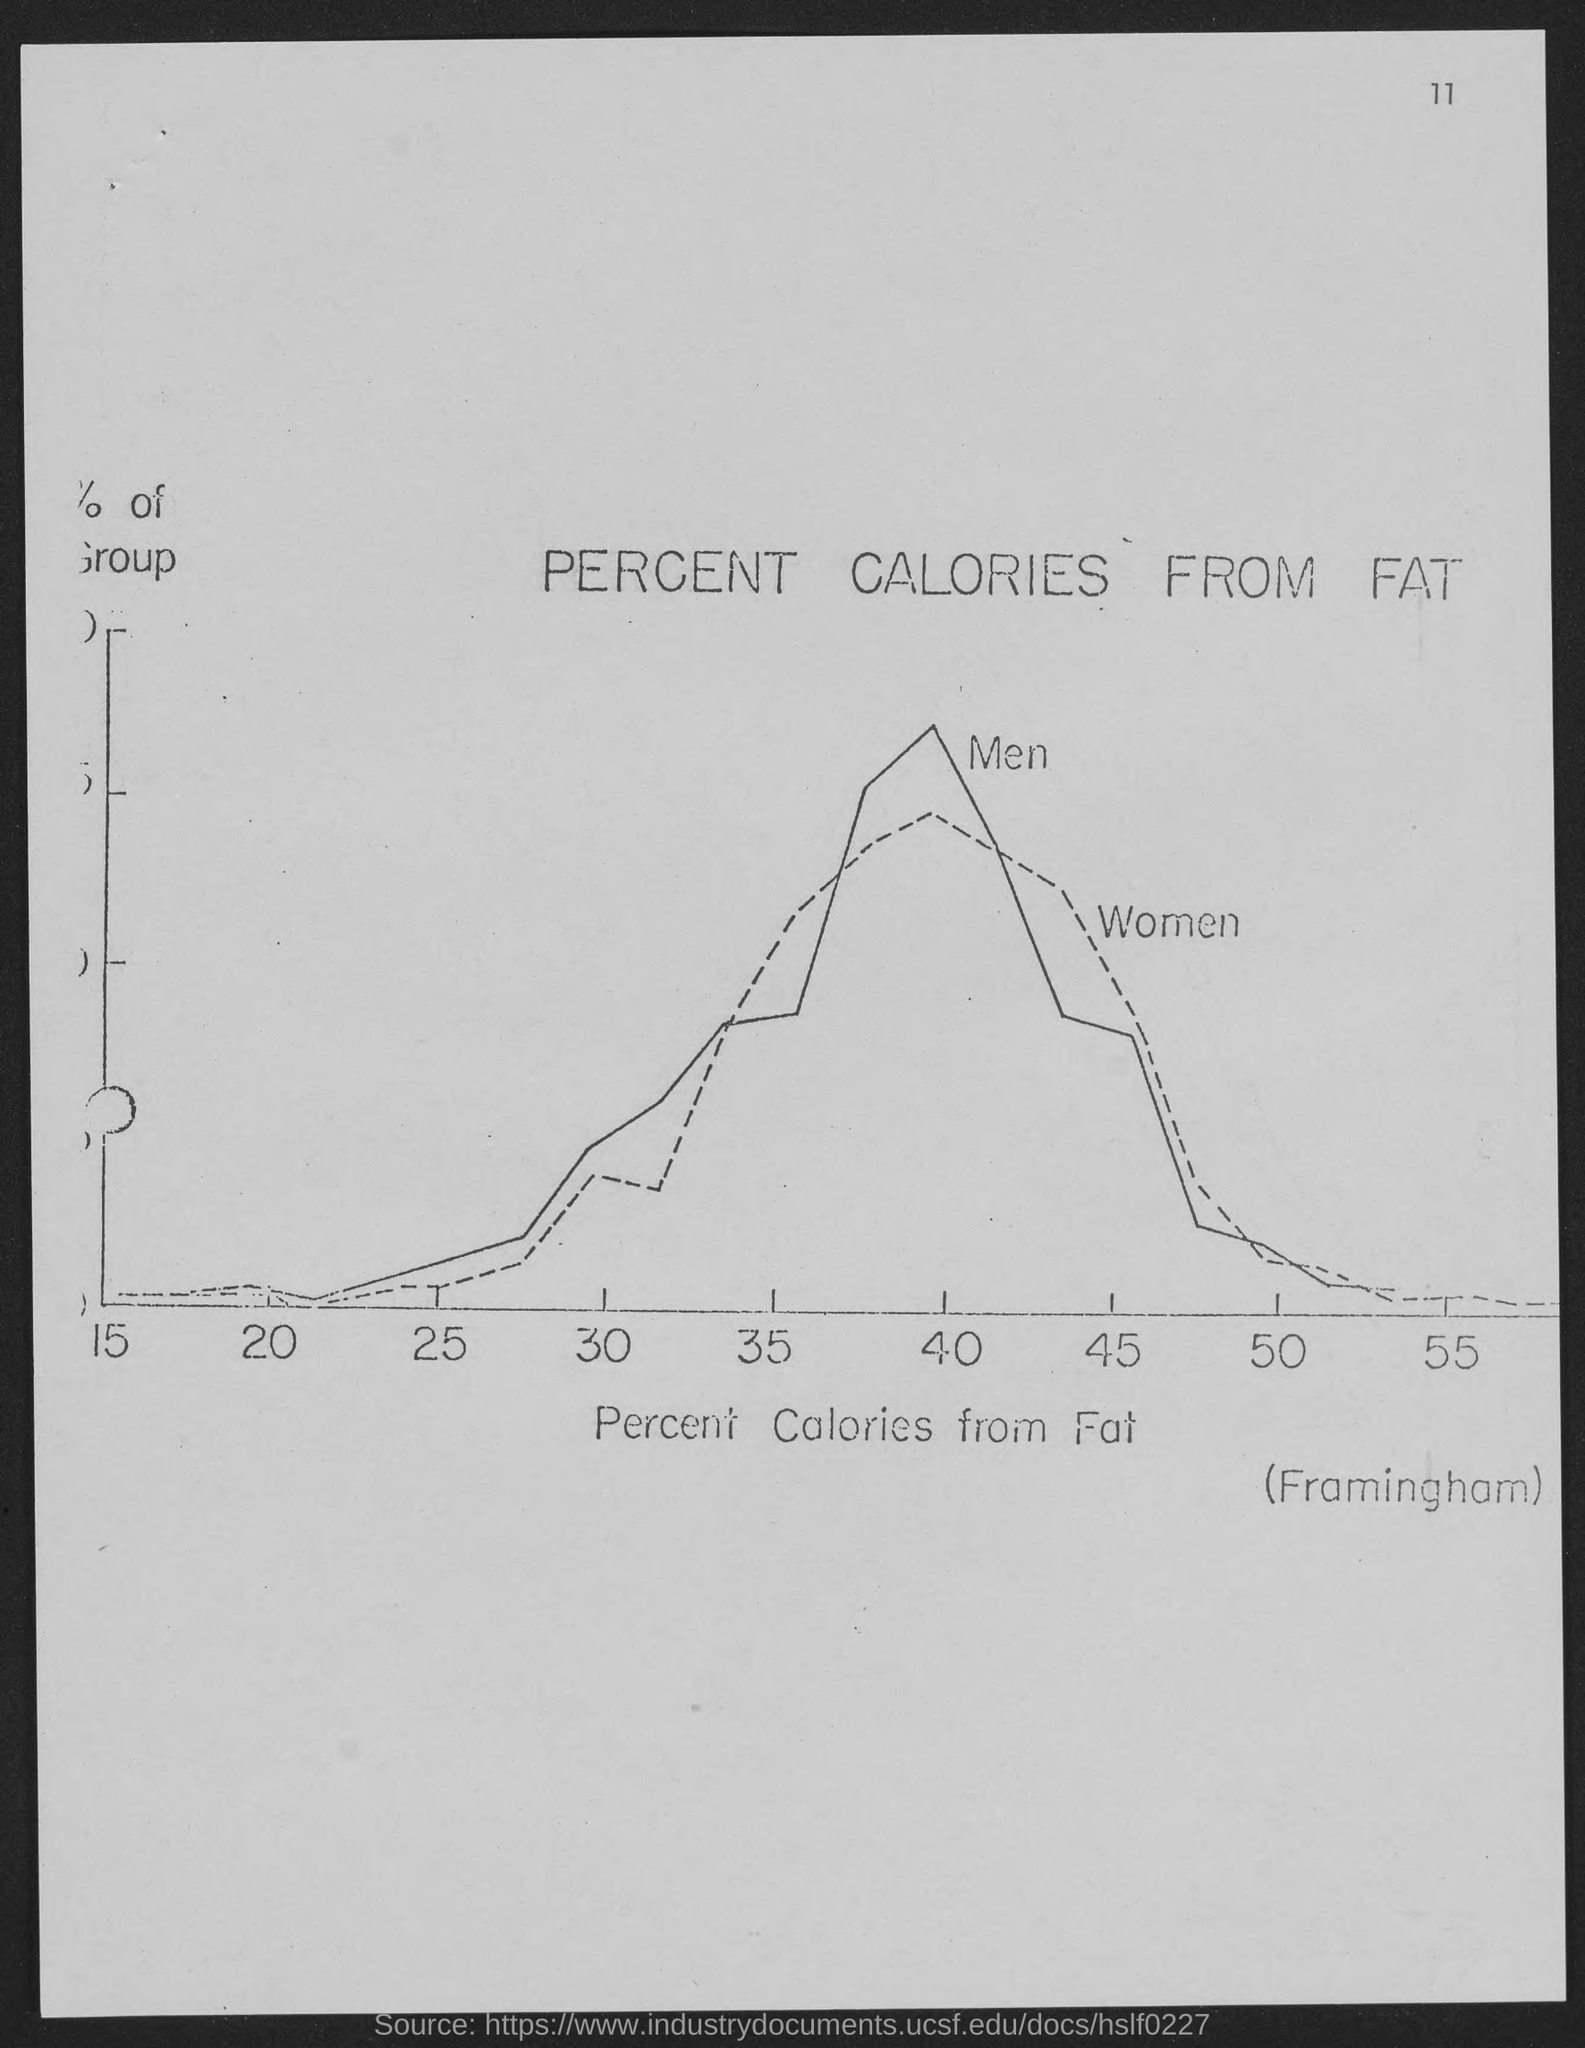Mention a couple of crucial points in this snapshot. The page number mentioned in this document is 11. The x-axis on the graph represents the percent of calories obtained from fat. 